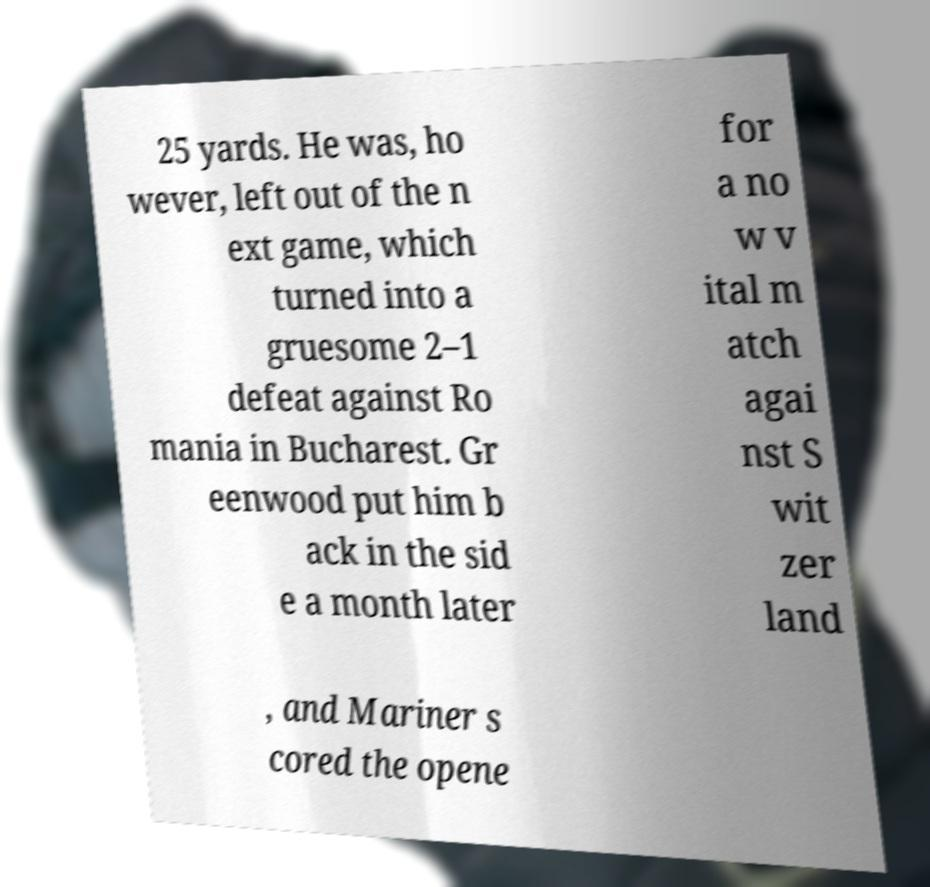What messages or text are displayed in this image? I need them in a readable, typed format. 25 yards. He was, ho wever, left out of the n ext game, which turned into a gruesome 2–1 defeat against Ro mania in Bucharest. Gr eenwood put him b ack in the sid e a month later for a no w v ital m atch agai nst S wit zer land , and Mariner s cored the opene 